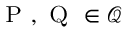<formula> <loc_0><loc_0><loc_500><loc_500>{ P } , { Q } \in { \mathcal { Q } }</formula> 